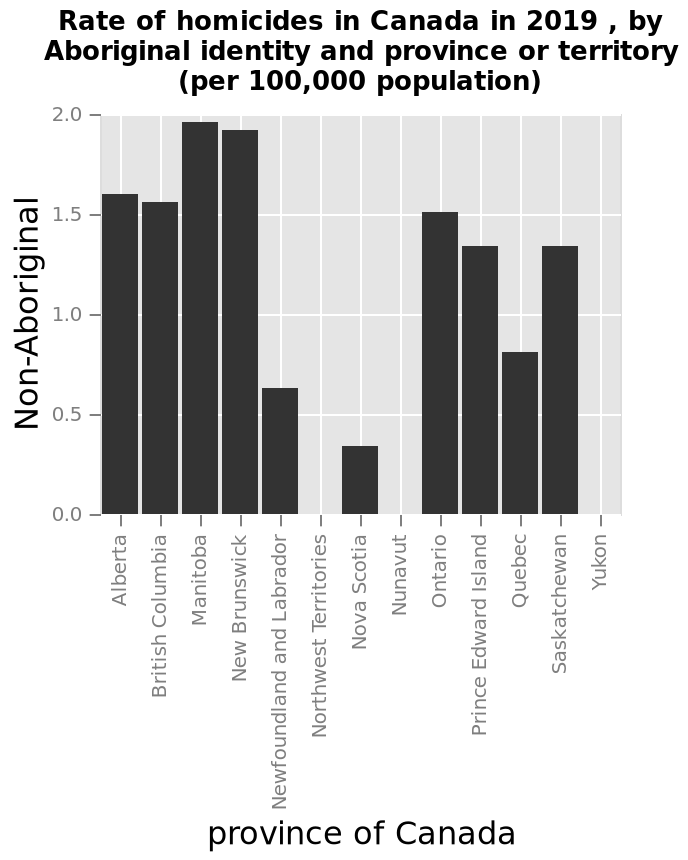<image>
Why does the bar graph indicate no Aboriginal homicides in the Northwest Territories, Yukon, and Nunavut regions in Canada from the 2019 data?  The absence of Aboriginal homicides in these regions could suggest that there are either no Aboriginal people residing in these areas or a very low number of non-Native Canadians who occupy them. please describe the details of the chart Rate of homicides in Canada in 2019 , by Aboriginal identity and province or territory (per 100,000 population) is a bar chart. Non-Aboriginal is defined using a linear scale from 0.0 to 2.0 along the y-axis. The x-axis shows province of Canada using a categorical scale from Alberta to Yukon. Could the lack of Aboriginal homicides in the Northwest Territories, Yukon, and Nunavut regions indicate something about the population of Aboriginal people in these areas?  Yes, the absence of Aboriginal homicides in these regions might imply that there are either no Aboriginal people residing there or a very small number of non-Native Canadians who occupy the region. 